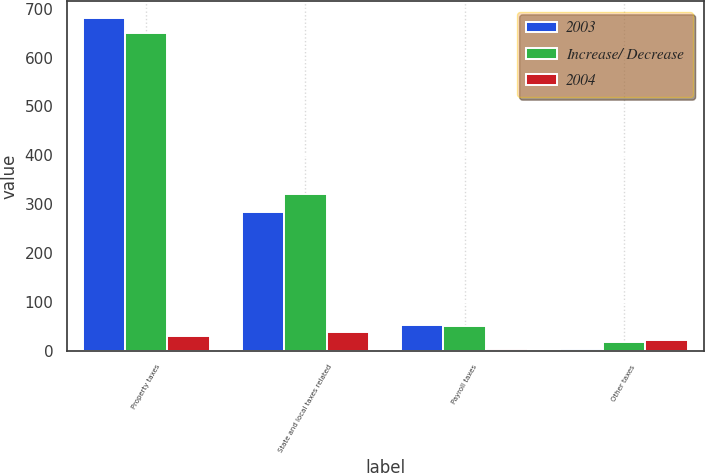Convert chart to OTSL. <chart><loc_0><loc_0><loc_500><loc_500><stacked_bar_chart><ecel><fcel>Property taxes<fcel>State and local taxes related<fcel>Payroll taxes<fcel>Other taxes<nl><fcel>2003<fcel>681<fcel>283<fcel>53<fcel>4<nl><fcel>Increase/ Decrease<fcel>651<fcel>321<fcel>50<fcel>18<nl><fcel>2004<fcel>30<fcel>38<fcel>3<fcel>22<nl></chart> 